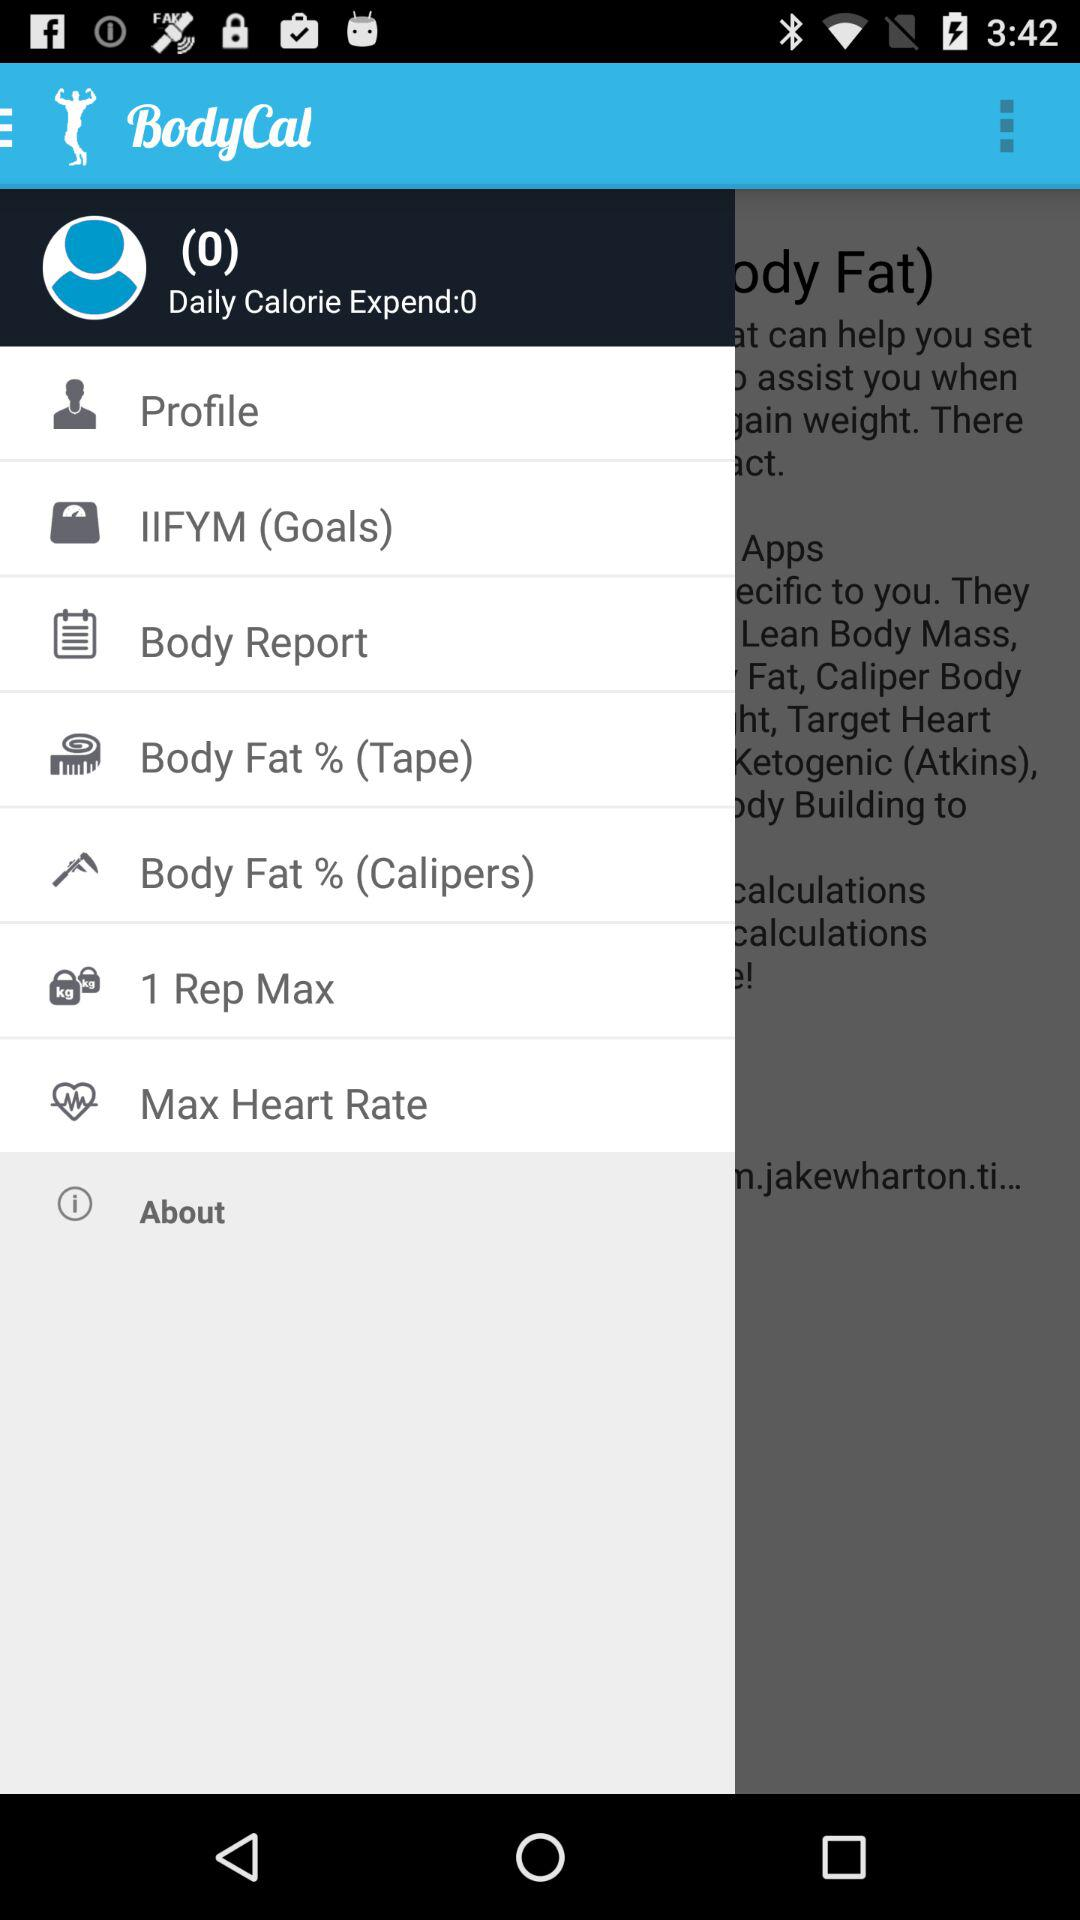What is the value in "Daily Calorie Expend"? The value in "Daily Calorie Expend" is 0. 